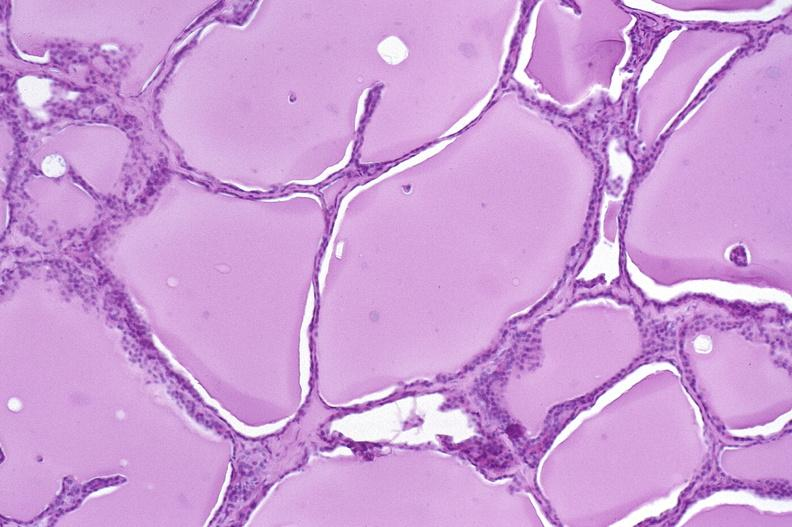what does this image show?
Answer the question using a single word or phrase. Thyroid gland 